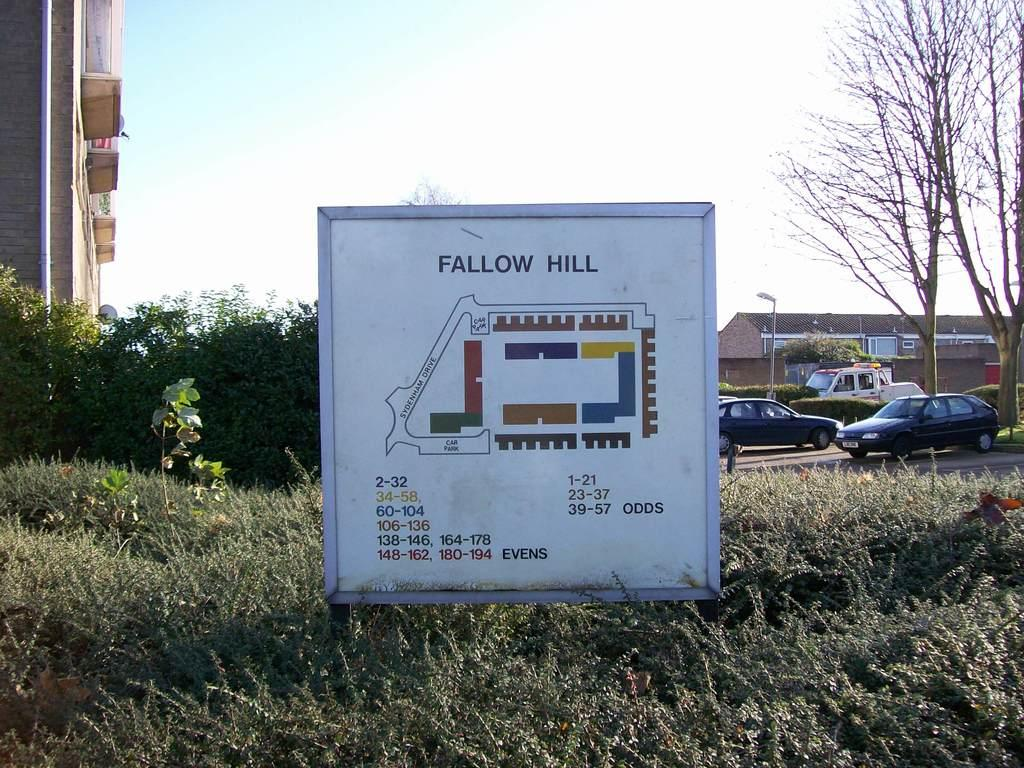What type of living organisms can be seen in the image? Plants can be seen in the image. What is located in the middle of the image? There is a sign board in the middle of the image. What can be seen in the background of the image? Buildings, trees, and vehicles can be seen in the background of the image. What is the tall, vertical object in the image? There is a pole in the image. Can you tell me how many hydrants are visible in the image? There are no hydrants present in the image. Is there a girl playing with the plants in the image? There is no girl present in the image. 